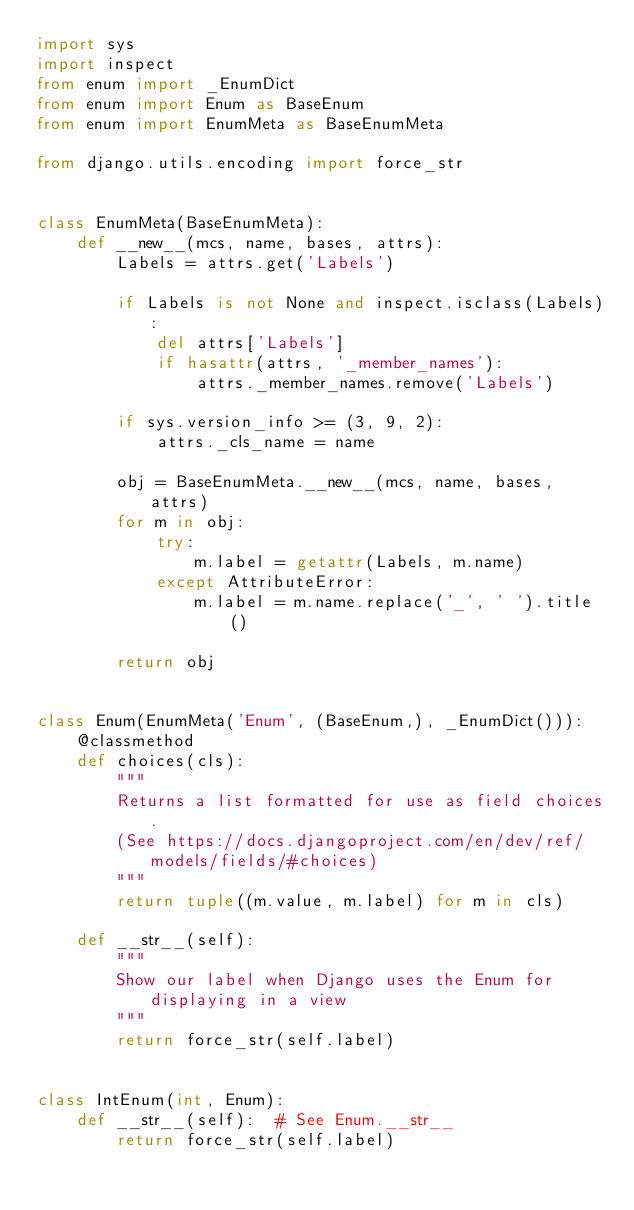Convert code to text. <code><loc_0><loc_0><loc_500><loc_500><_Python_>import sys
import inspect
from enum import _EnumDict
from enum import Enum as BaseEnum
from enum import EnumMeta as BaseEnumMeta

from django.utils.encoding import force_str


class EnumMeta(BaseEnumMeta):
    def __new__(mcs, name, bases, attrs):
        Labels = attrs.get('Labels')

        if Labels is not None and inspect.isclass(Labels):
            del attrs['Labels']
            if hasattr(attrs, '_member_names'):
                attrs._member_names.remove('Labels')

        if sys.version_info >= (3, 9, 2):
            attrs._cls_name = name

        obj = BaseEnumMeta.__new__(mcs, name, bases, attrs)
        for m in obj:
            try:
                m.label = getattr(Labels, m.name)
            except AttributeError:
                m.label = m.name.replace('_', ' ').title()

        return obj


class Enum(EnumMeta('Enum', (BaseEnum,), _EnumDict())):
    @classmethod
    def choices(cls):
        """
        Returns a list formatted for use as field choices.
        (See https://docs.djangoproject.com/en/dev/ref/models/fields/#choices)
        """
        return tuple((m.value, m.label) for m in cls)

    def __str__(self):
        """
        Show our label when Django uses the Enum for displaying in a view
        """
        return force_str(self.label)


class IntEnum(int, Enum):
    def __str__(self):  # See Enum.__str__
        return force_str(self.label)
</code> 